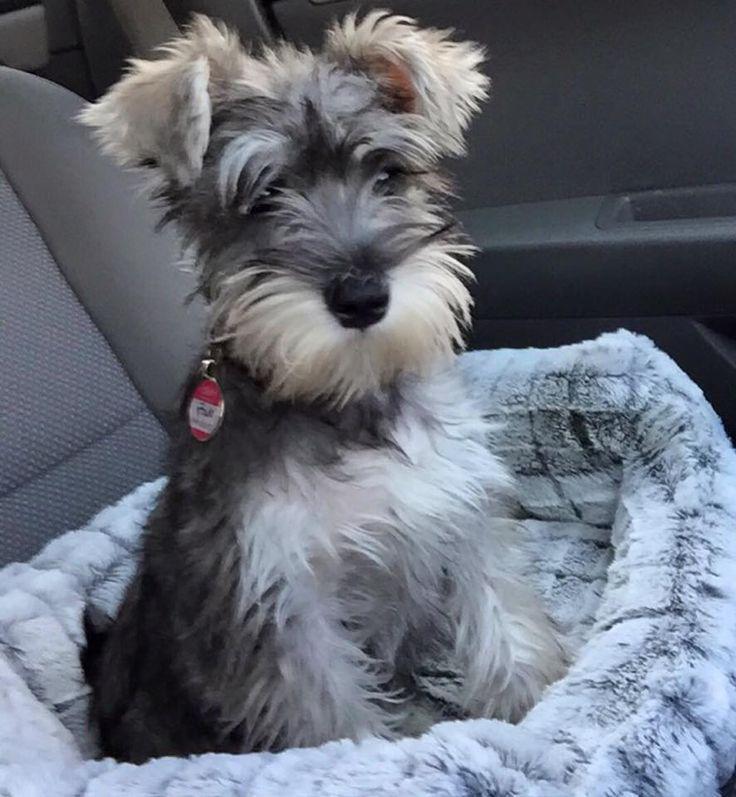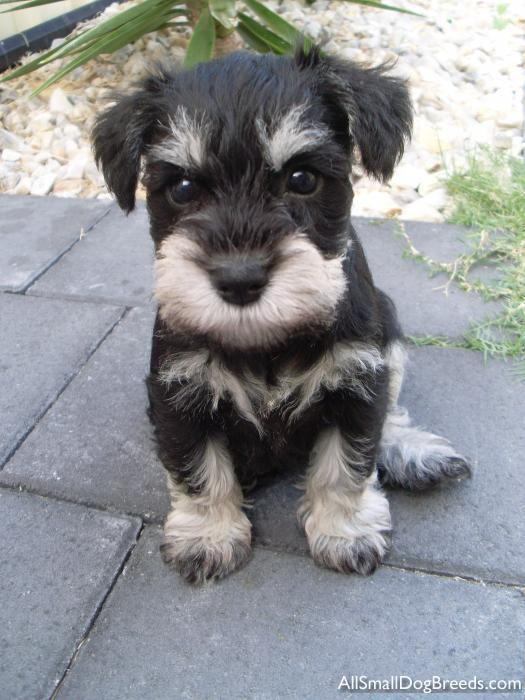The first image is the image on the left, the second image is the image on the right. For the images shown, is this caption "A dog is chewing on something in one of the photos." true? Answer yes or no. No. The first image is the image on the left, the second image is the image on the right. Evaluate the accuracy of this statement regarding the images: "In one of the images there is a dog chewing a dog bone.". Is it true? Answer yes or no. No. 